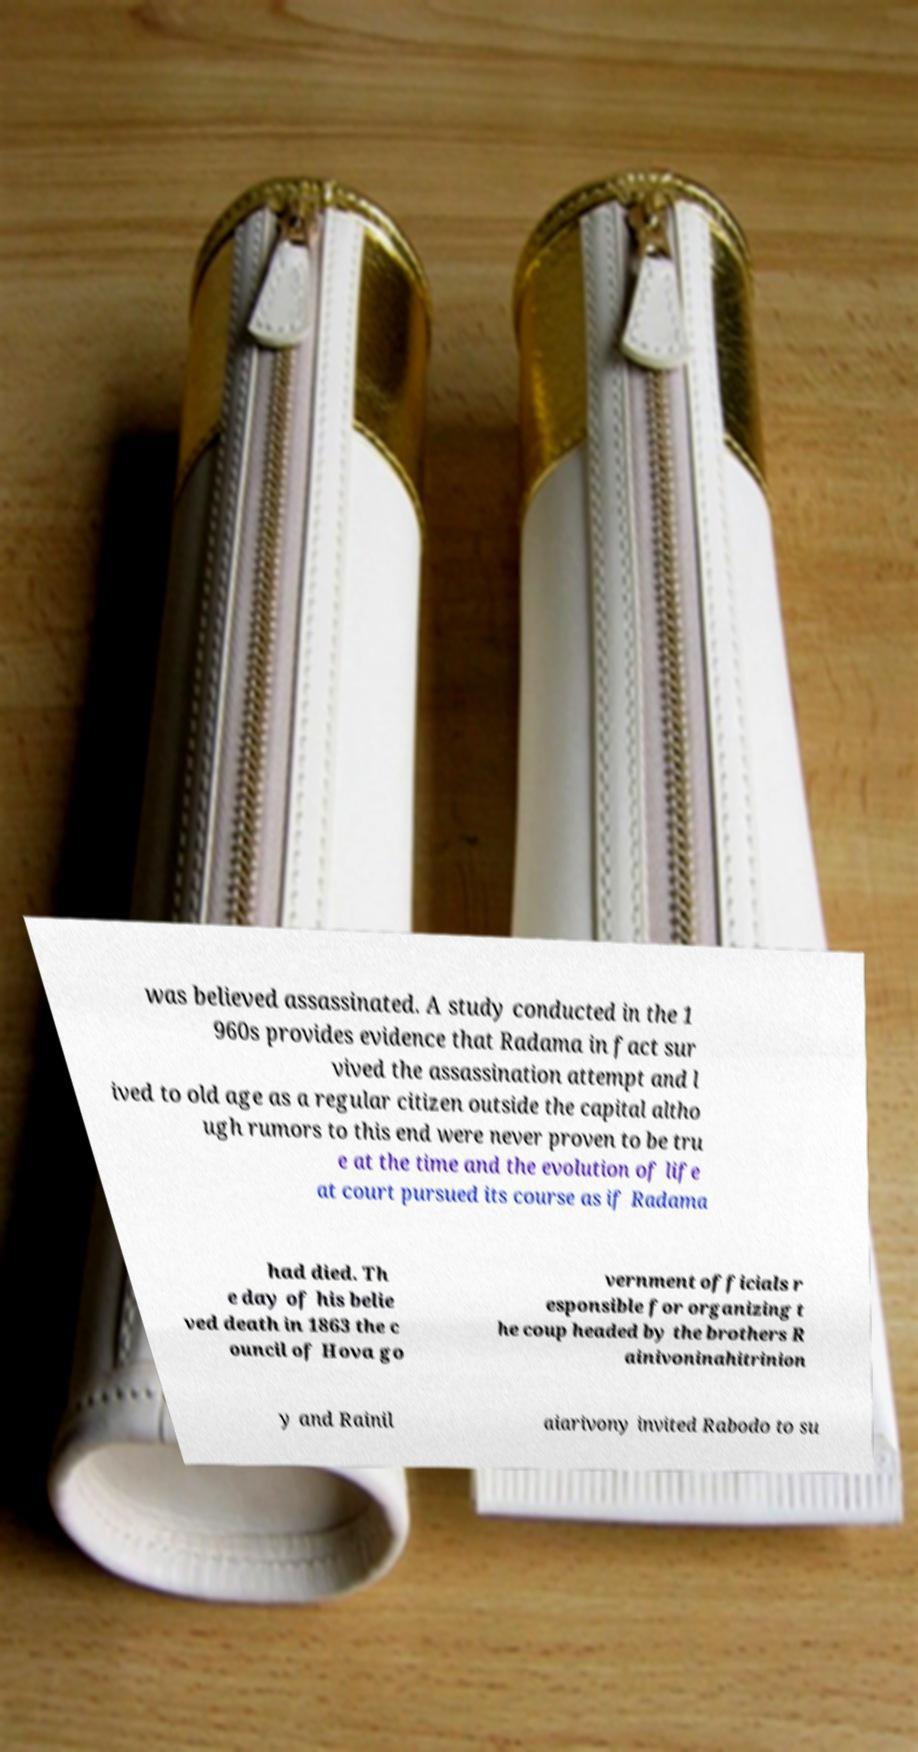Can you read and provide the text displayed in the image?This photo seems to have some interesting text. Can you extract and type it out for me? was believed assassinated. A study conducted in the 1 960s provides evidence that Radama in fact sur vived the assassination attempt and l ived to old age as a regular citizen outside the capital altho ugh rumors to this end were never proven to be tru e at the time and the evolution of life at court pursued its course as if Radama had died. Th e day of his belie ved death in 1863 the c ouncil of Hova go vernment officials r esponsible for organizing t he coup headed by the brothers R ainivoninahitrinion y and Rainil aiarivony invited Rabodo to su 